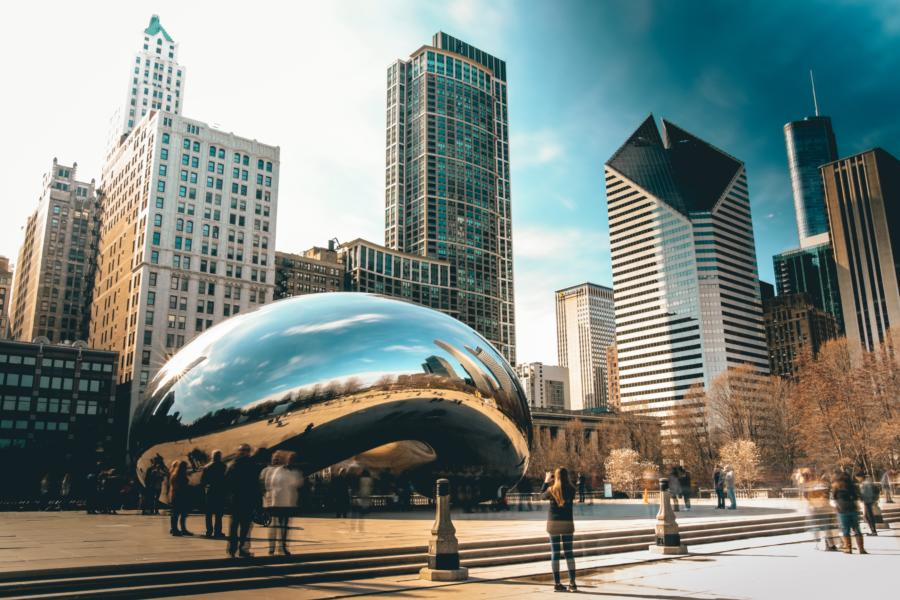Can you describe the architectural contrast between the old and the new buildings surrounding the Cloud Gate? Surrounding the Cloud Gate, there is a stark architectural contrast that encapsulates Chicago’s historical evolution. On one side, the modern skyscrapers with their glass facades symbolize technological advancement and contemporary design. On the other, older stone buildings represent Chicago’s rich architectural heritage, marked by ornate detailing and robust materials. This juxtaposition not only enhances the city's diverse urban tapestry but also creates a visual dialogue between different eras of architectural styles. 